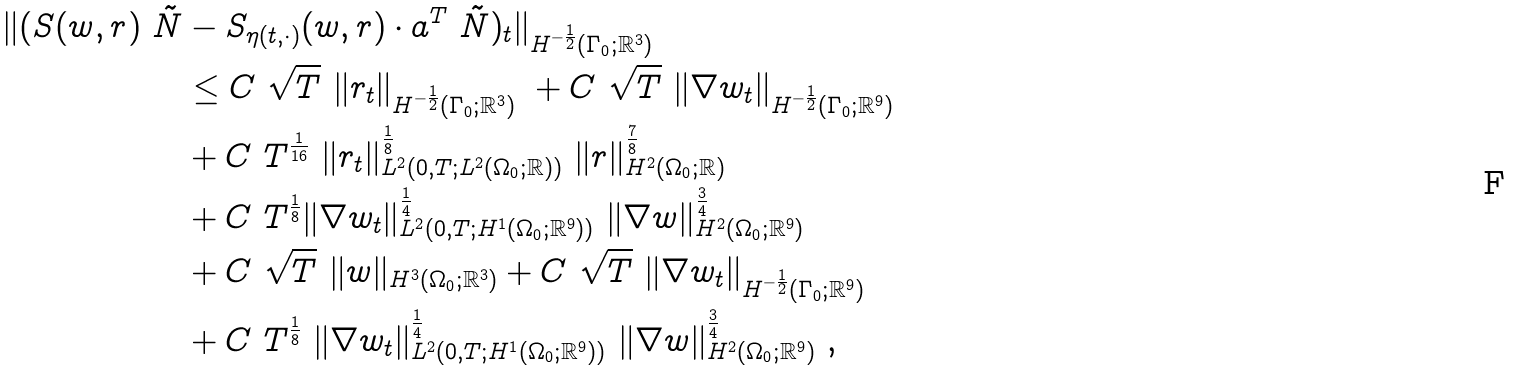Convert formula to latex. <formula><loc_0><loc_0><loc_500><loc_500>\| ( S ( w , r ) \ \tilde { N } & - S _ { \eta ( t , \cdot ) } ( w , r ) \cdot a ^ { T } \ \tilde { N } ) _ { t } \| _ { H ^ { - \frac { 1 } { 2 } } ( { \Gamma _ { 0 } } ; { \mathbb { R } } ^ { 3 } ) } \\ & \leq C \ \sqrt { T } \ \| r _ { t } \| _ { H ^ { - \frac { 1 } { 2 } } ( { \Gamma _ { 0 } } ; { \mathbb { R } } ^ { 3 } ) } \ + C \ \sqrt { T } \ \| \nabla w _ { t } \| _ { H ^ { - \frac { 1 } { 2 } } ( { \Gamma _ { 0 } } ; { \mathbb { R } } ^ { 9 } ) } \\ & + C \ T ^ { \frac { 1 } { 1 6 } } \ \| r _ { t } \| ^ { \frac { 1 } { 8 } } _ { L ^ { 2 } ( 0 , T ; L ^ { 2 } ( { \Omega _ { 0 } } ; { \mathbb { R } } ) ) } \ \| r \| ^ { \frac { 7 } { 8 } } _ { H ^ { 2 } ( { \Omega _ { 0 } } ; { \mathbb { R } } ) } \\ & + C \ T ^ { \frac { 1 } { 8 } } \| \nabla w _ { t } \| ^ { \frac { 1 } { 4 } } _ { L ^ { 2 } ( 0 , T ; H ^ { 1 } ( { \Omega _ { 0 } } ; { \mathbb { R } } ^ { 9 } ) ) } \ \| \nabla w \| ^ { \frac { 3 } { 4 } } _ { H ^ { 2 } ( { \Omega _ { 0 } } ; { \mathbb { R } } ^ { 9 } ) } \\ & + C \ \sqrt { T } \ \| w \| _ { H ^ { 3 } ( { \Omega _ { 0 } } ; { \mathbb { R } } ^ { 3 } ) } + C \ \sqrt { T } \ \| \nabla w _ { t } \| _ { H ^ { - \frac { 1 } { 2 } } ( { \Gamma _ { 0 } } ; { \mathbb { R } } ^ { 9 } ) } \\ & + C \ T ^ { \frac { 1 } { 8 } } \ \| \nabla w _ { t } \| ^ { \frac { 1 } { 4 } } _ { L ^ { 2 } ( 0 , T ; H ^ { 1 } ( { \Omega _ { 0 } } ; { \mathbb { R } } ^ { 9 } ) ) } \ \| \nabla w \| ^ { \frac { 3 } { 4 } } _ { H ^ { 2 } ( { \Omega _ { 0 } } ; { \mathbb { R } } ^ { 9 } ) } \ ,</formula> 